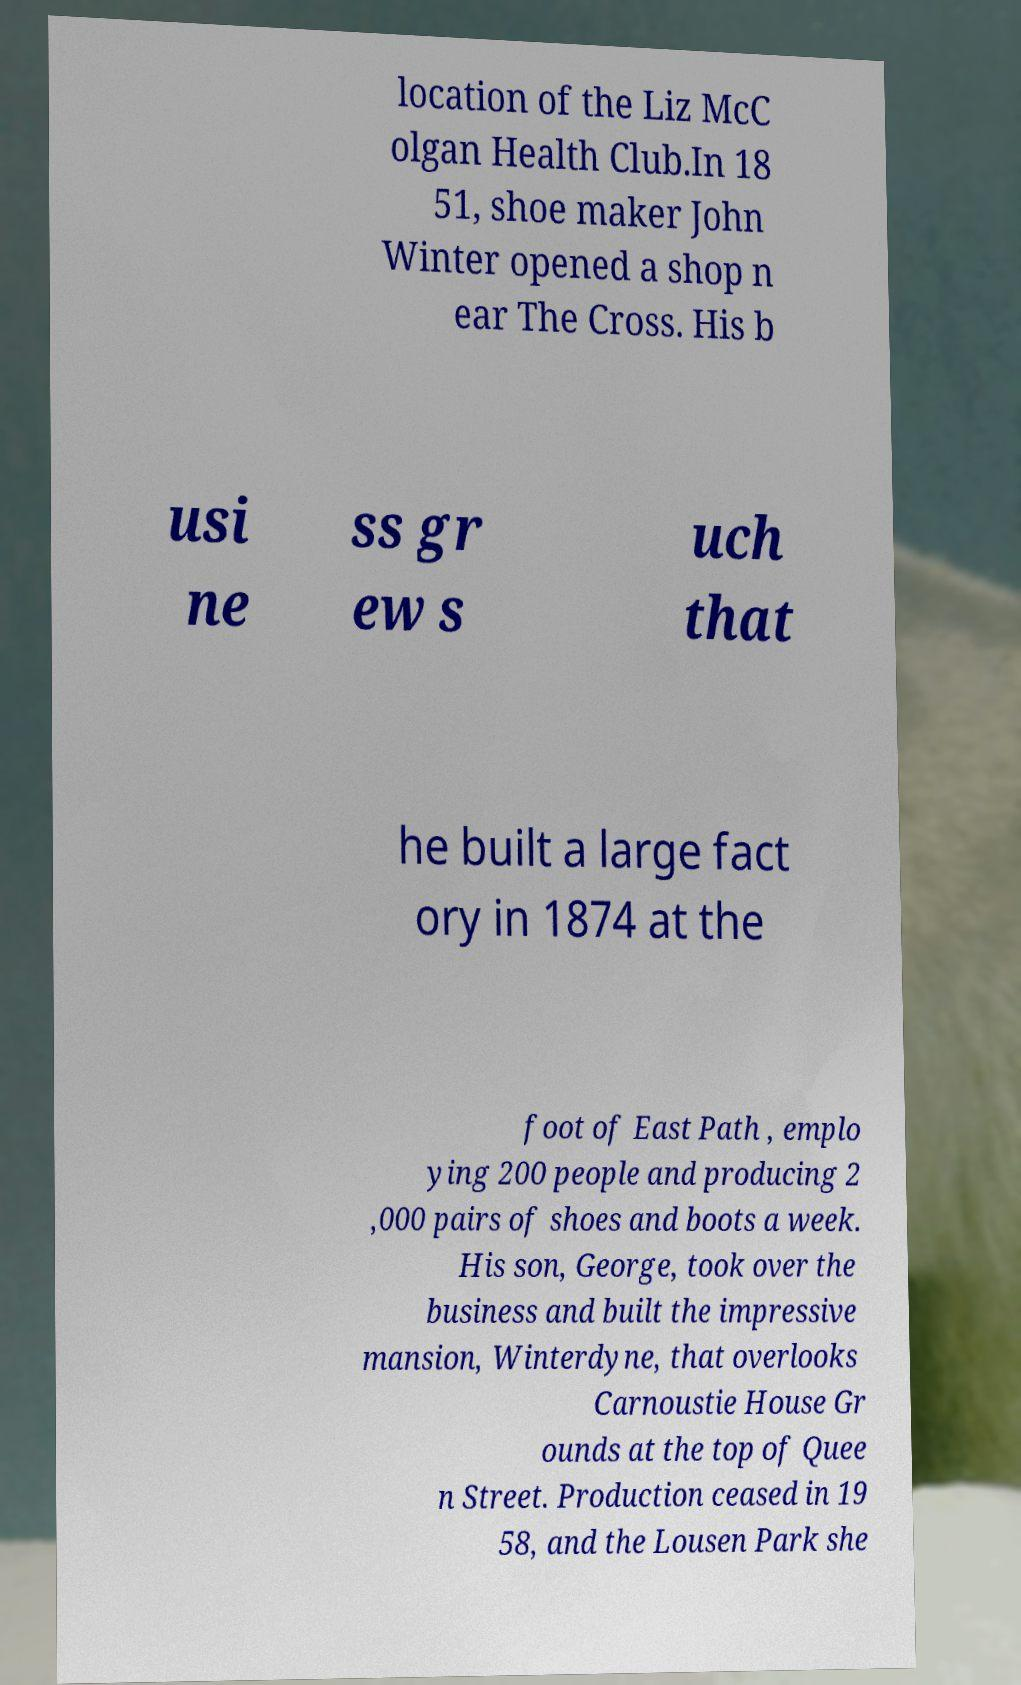Can you read and provide the text displayed in the image?This photo seems to have some interesting text. Can you extract and type it out for me? location of the Liz McC olgan Health Club.In 18 51, shoe maker John Winter opened a shop n ear The Cross. His b usi ne ss gr ew s uch that he built a large fact ory in 1874 at the foot of East Path , emplo ying 200 people and producing 2 ,000 pairs of shoes and boots a week. His son, George, took over the business and built the impressive mansion, Winterdyne, that overlooks Carnoustie House Gr ounds at the top of Quee n Street. Production ceased in 19 58, and the Lousen Park she 